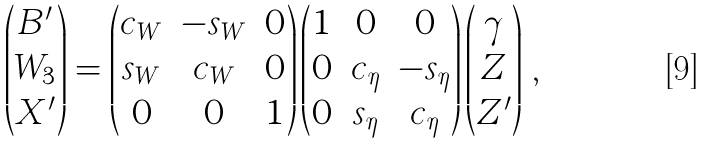Convert formula to latex. <formula><loc_0><loc_0><loc_500><loc_500>\begin{pmatrix} B ^ { \prime } \\ W _ { 3 } \\ X ^ { \prime } \end{pmatrix} = \begin{pmatrix} c _ { W } & - s _ { W } & 0 \\ s _ { W } & c _ { W } & 0 \\ 0 & 0 & 1 \end{pmatrix} \begin{pmatrix} 1 & 0 & 0 \\ 0 & c _ { \eta } & - s _ { \eta } \\ 0 & s _ { \eta } & c _ { \eta } \end{pmatrix} \begin{pmatrix} \gamma \\ Z \\ Z ^ { \prime } \end{pmatrix} \, ,</formula> 